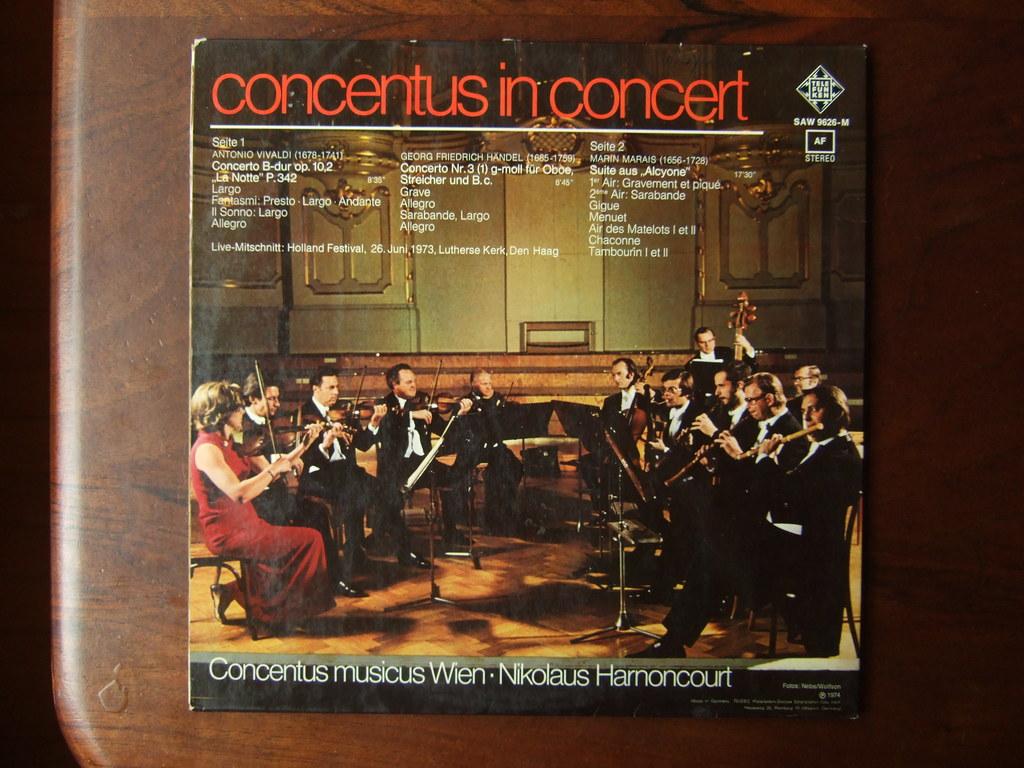Is this a really old album?
Provide a short and direct response. Yes. 